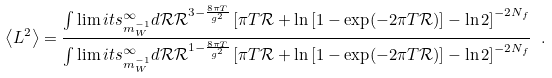<formula> <loc_0><loc_0><loc_500><loc_500>\left < L ^ { 2 } \right > = \frac { \int \lim i t s _ { m _ { W } ^ { - 1 } } ^ { \infty } d { \mathcal { R } } { \mathcal { R } } ^ { 3 - \frac { 8 \pi T } { g ^ { 2 } } } \left [ \pi T { \mathcal { R } } + \ln \left [ 1 - \exp ( - 2 \pi T { \mathcal { R } } ) \right ] - \ln 2 \right ] ^ { - 2 N _ { f } } } { \int \lim i t s _ { m _ { W } ^ { - 1 } } ^ { \infty } d { \mathcal { R } } { \mathcal { R } } ^ { 1 - \frac { 8 \pi T } { g ^ { 2 } } } \left [ \pi T { \mathcal { R } } + \ln \left [ 1 - \exp ( - 2 \pi T { \mathcal { R } } ) \right ] - \ln 2 \right ] ^ { - 2 N _ { f } } } \ .</formula> 